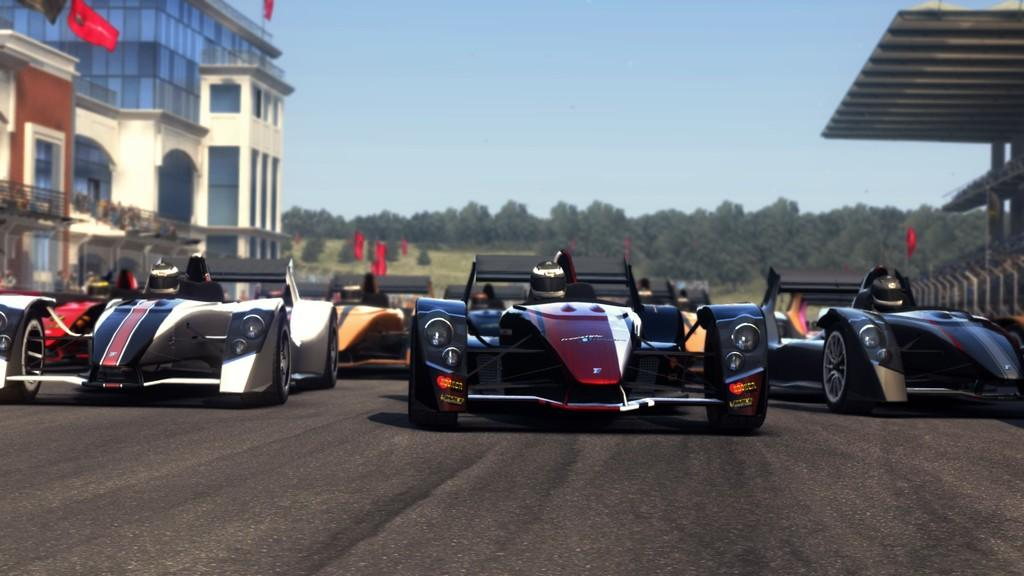What type of vehicles are on the road in the image? There are sports cars on the road in the image. Who might be inside the sports cars? There are people in the cars. What can be seen in the distance behind the sports cars? There are buildings, trees, flags, and the sky visible in the background of the image. Can you see a parent holding a worm in the image? There is no parent or worm present in the image. 